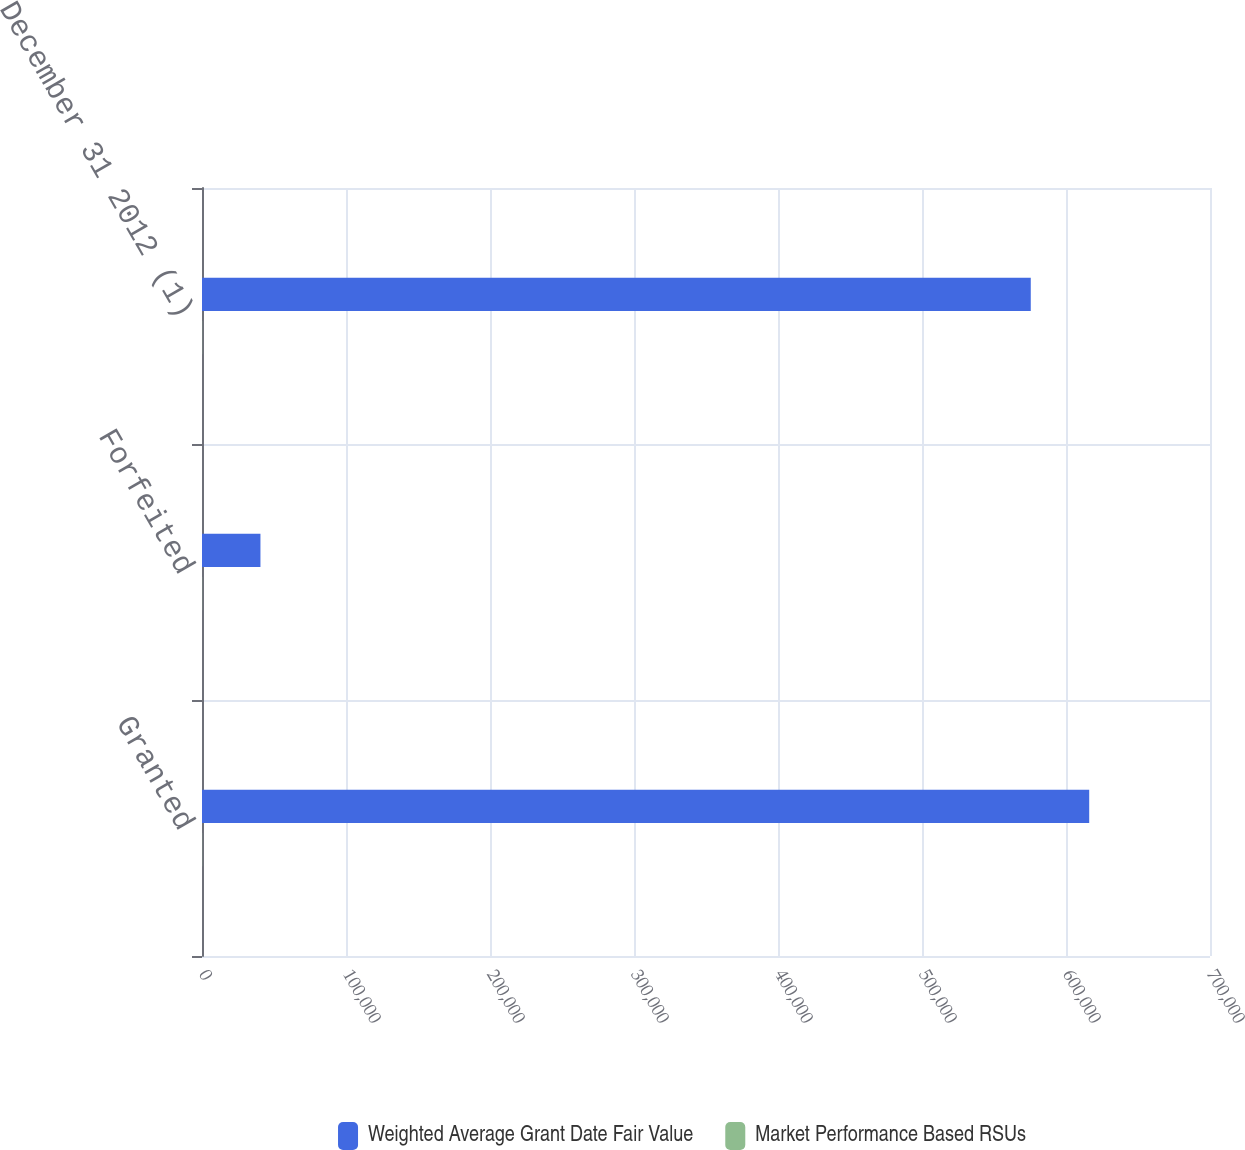Convert chart to OTSL. <chart><loc_0><loc_0><loc_500><loc_500><stacked_bar_chart><ecel><fcel>Granted<fcel>Forfeited<fcel>December 31 2012 (1)<nl><fcel>Weighted Average Grant Date Fair Value<fcel>616117<fcel>40585<fcel>575532<nl><fcel>Market Performance Based RSUs<fcel>115.03<fcel>115.03<fcel>115.03<nl></chart> 